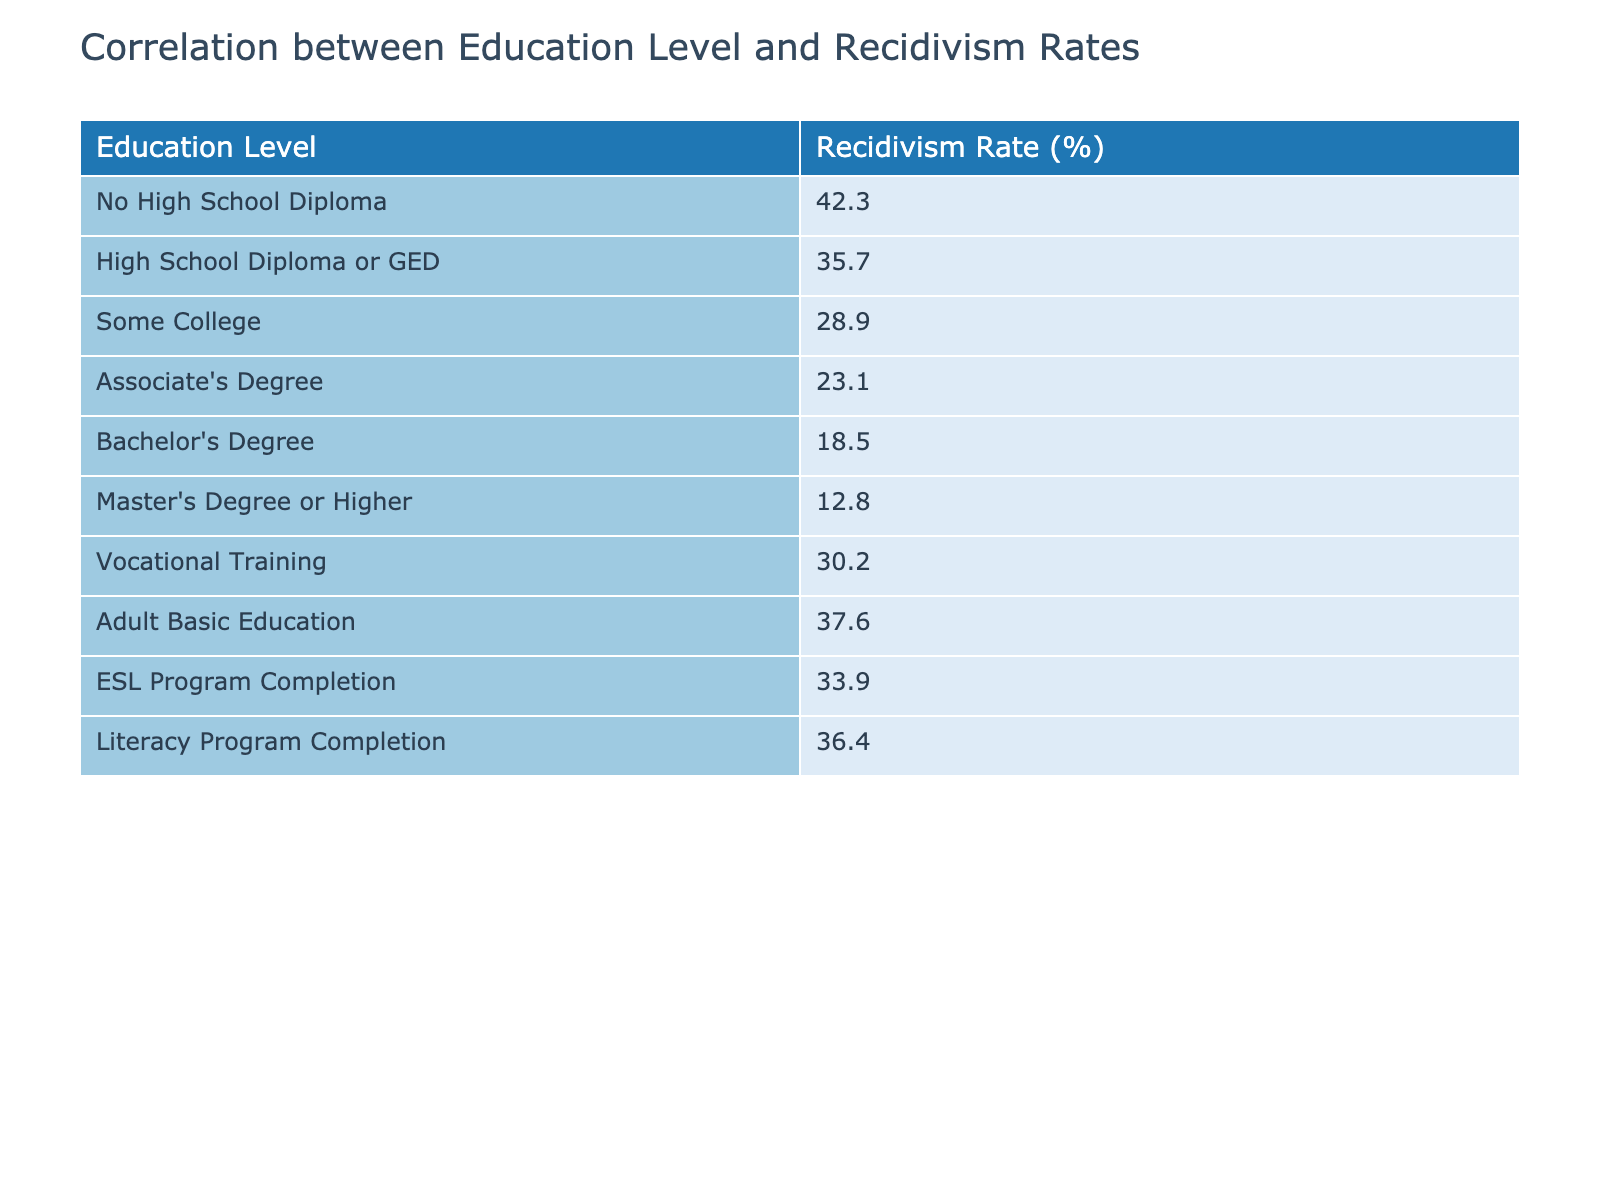What is the recidivism rate for individuals with a Bachelor's Degree? According to the table, the recidivism rate for individuals with a Bachelor's Degree is listed as 18.5%.
Answer: 18.5% Which education level has the highest recidivism rate? The highest recidivism rate is for individuals with No High School Diploma, at 42.3%.
Answer: No High School Diploma What is the difference in recidivism rates between those with a high school diploma and those with an associate's degree? The recidivism rate for those with a high school diploma is 35.7% and for those with an associate's degree is 23.1%. The difference is calculated as 35.7% - 23.1% = 12.6%.
Answer: 12.6% Is the recidivism rate for individuals with vocational training higher than for those with some college education? The recidivism rate for individuals with vocational training is 30.2%, while for some college education, it is 28.9%. Thus, the statement is true; vocational training has a higher recidivism rate.
Answer: Yes What is the average recidivism rate for all education levels listed in the table? To find the average, we sum all recidivism rates: 42.3 + 35.7 + 28.9 + 23.1 + 18.5 + 12.8 + 30.2 + 37.6 + 33.9 + 36.4 = 328.4. There are 10 levels, so the average is 328.4 / 10 = 32.84%.
Answer: 32.84% If someone completes an Adult Basic Education program, what range of recidivism rates can they expect based on this data? The recidivism rate for Adult Basic Education is 37.6%. The range of education levels surrounding it shows that it is lower than No High School Diploma (42.3%) and higher than those with an Associate's Degree (23.1%).
Answer: 37.6% Identify one education level that has a lower recidivism rate than an individual with a Master's Degree or Higher. According to the table, the recidivism rate for both the Associate's Degree (23.1%) and for individuals with a Bachelor's Degree (18.5%) are lower than the rate for a Master's Degree or Higher, which is 12.8%.
Answer: Associate's Degree or Bachelor's Degree Which education level has a recidivism rate that is closest to the average for all groups? The average recidivism rate is 32.84%. Looking at the table, the rate closest to this average is from individuals who have completed an ESL Program, which is 33.9%.
Answer: ESL Program Completion Is there a linear pattern in the decrease of recidivism rates as education levels increase? The data reflects a trend where recidivism rates decrease as education levels increase, but there are variations, especially between vocational training (30.2%) and some college education (28.9%). Therefore, while there's a general trend, it's not perfectly linear.
Answer: No 